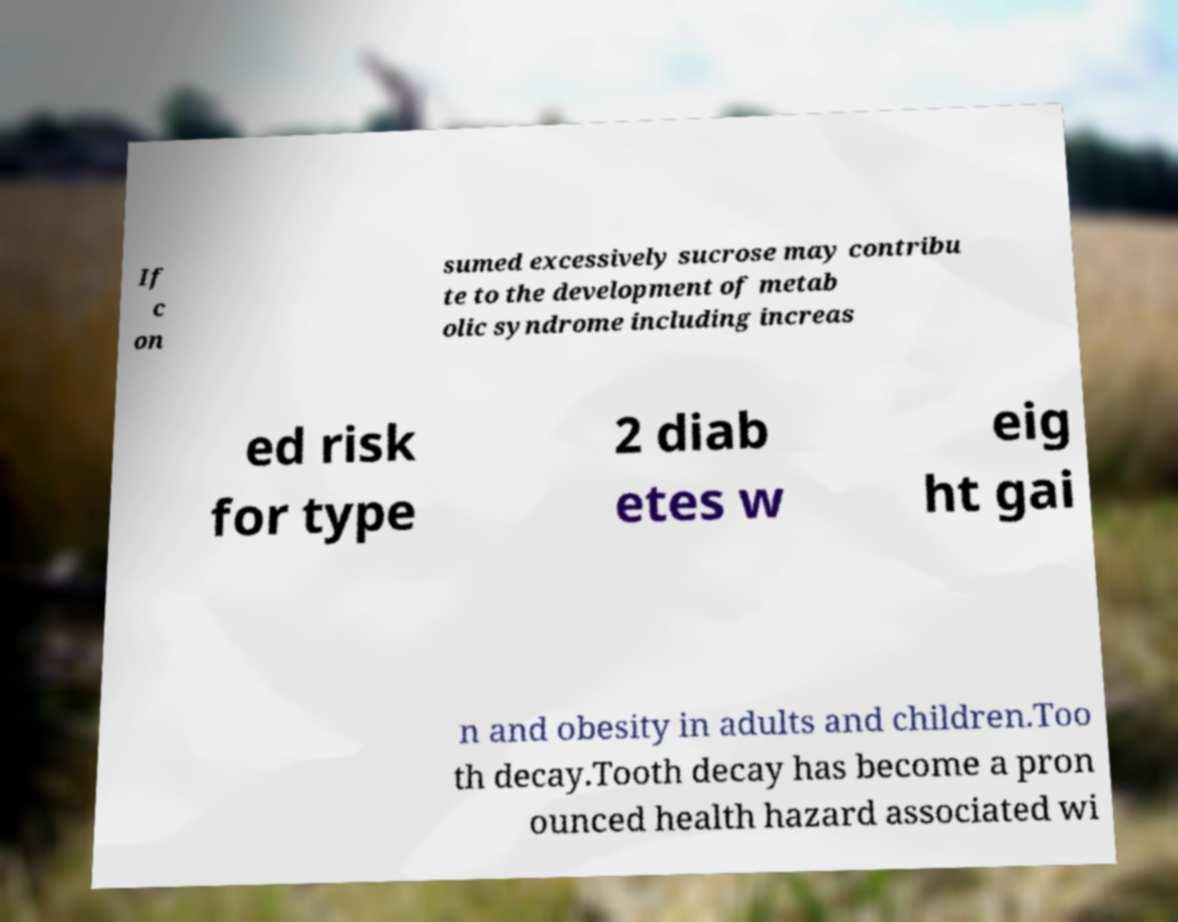Please read and relay the text visible in this image. What does it say? If c on sumed excessively sucrose may contribu te to the development of metab olic syndrome including increas ed risk for type 2 diab etes w eig ht gai n and obesity in adults and children.Too th decay.Tooth decay has become a pron ounced health hazard associated wi 